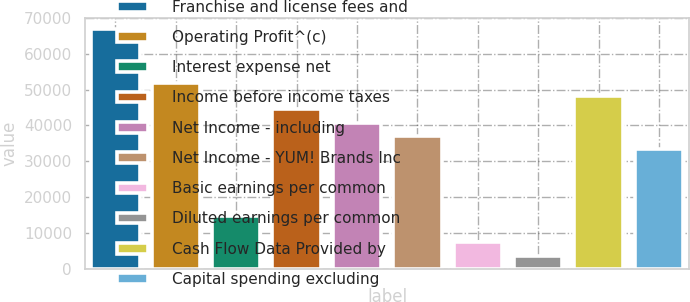Convert chart. <chart><loc_0><loc_0><loc_500><loc_500><bar_chart><fcel>Franchise and license fees and<fcel>Operating Profit^(c)<fcel>Interest expense net<fcel>Income before income taxes<fcel>Net Income - including<fcel>Net Income - YUM! Brands Inc<fcel>Basic earnings per common<fcel>Diluted earnings per common<fcel>Cash Flow Data Provided by<fcel>Capital spending excluding<nl><fcel>66743.4<fcel>51911.7<fcel>14832.5<fcel>44495.8<fcel>40787.9<fcel>37080<fcel>7416.64<fcel>3708.72<fcel>48203.8<fcel>33372.1<nl></chart> 